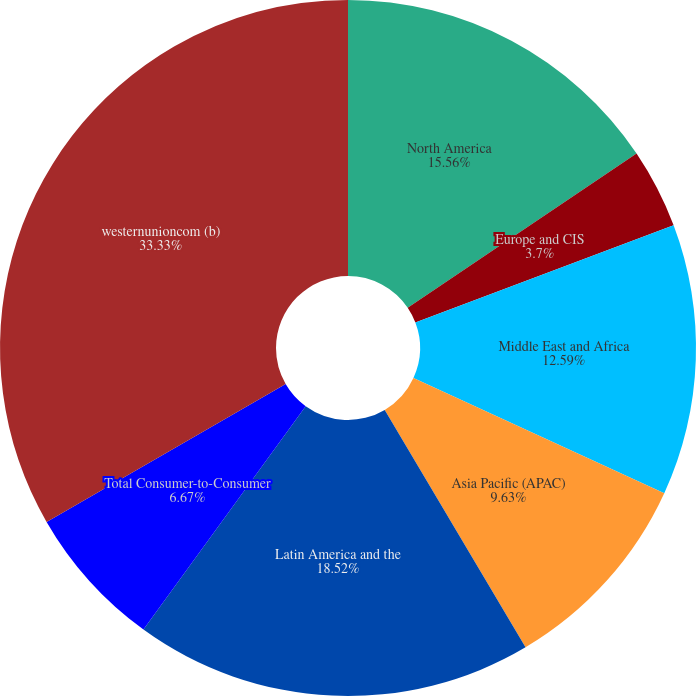Convert chart. <chart><loc_0><loc_0><loc_500><loc_500><pie_chart><fcel>North America<fcel>Europe and CIS<fcel>Middle East and Africa<fcel>Asia Pacific (APAC)<fcel>Latin America and the<fcel>Total Consumer-to-Consumer<fcel>westernunioncom (b)<nl><fcel>15.56%<fcel>3.7%<fcel>12.59%<fcel>9.63%<fcel>18.52%<fcel>6.67%<fcel>33.33%<nl></chart> 